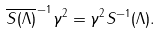<formula> <loc_0><loc_0><loc_500><loc_500>\overline { S ( \Lambda ) } ^ { \, - 1 } \gamma ^ { 2 } = \gamma ^ { 2 } S ^ { - 1 } ( \Lambda ) .</formula> 